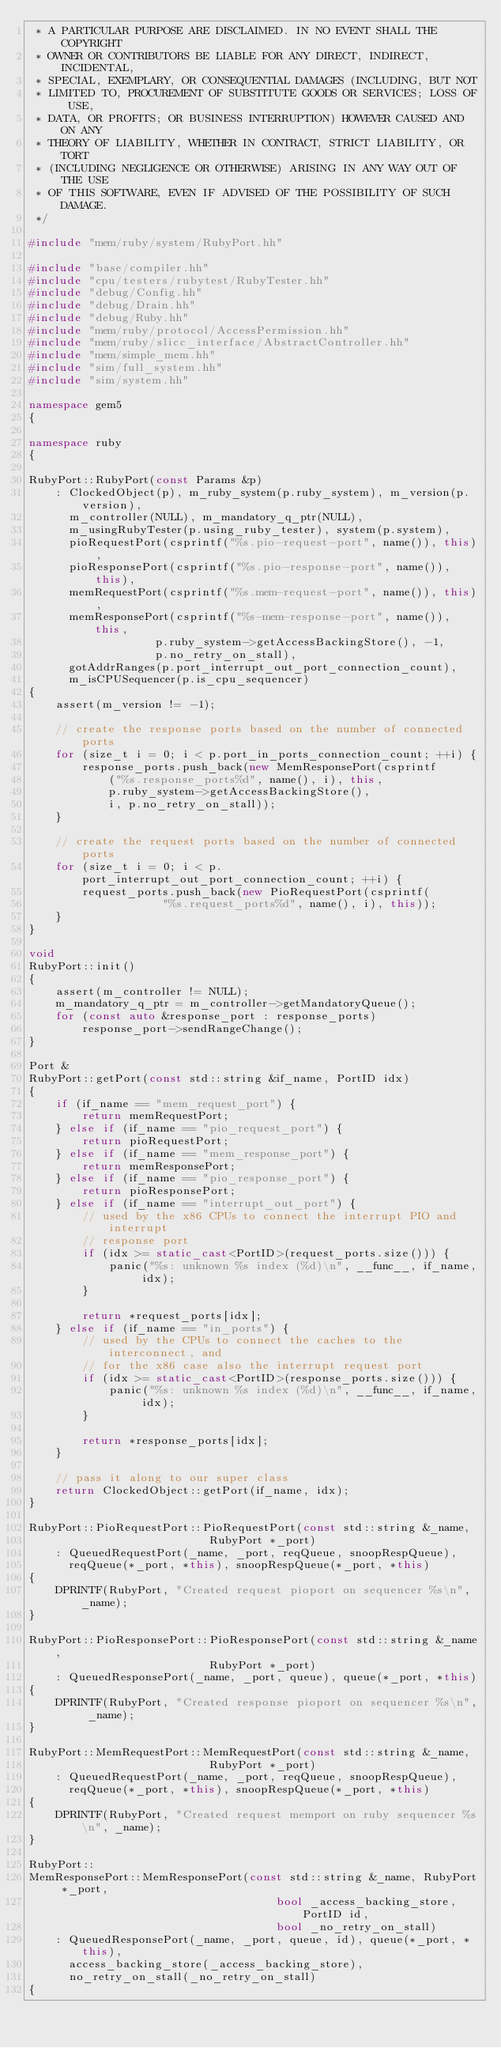<code> <loc_0><loc_0><loc_500><loc_500><_C++_> * A PARTICULAR PURPOSE ARE DISCLAIMED. IN NO EVENT SHALL THE COPYRIGHT
 * OWNER OR CONTRIBUTORS BE LIABLE FOR ANY DIRECT, INDIRECT, INCIDENTAL,
 * SPECIAL, EXEMPLARY, OR CONSEQUENTIAL DAMAGES (INCLUDING, BUT NOT
 * LIMITED TO, PROCUREMENT OF SUBSTITUTE GOODS OR SERVICES; LOSS OF USE,
 * DATA, OR PROFITS; OR BUSINESS INTERRUPTION) HOWEVER CAUSED AND ON ANY
 * THEORY OF LIABILITY, WHETHER IN CONTRACT, STRICT LIABILITY, OR TORT
 * (INCLUDING NEGLIGENCE OR OTHERWISE) ARISING IN ANY WAY OUT OF THE USE
 * OF THIS SOFTWARE, EVEN IF ADVISED OF THE POSSIBILITY OF SUCH DAMAGE.
 */

#include "mem/ruby/system/RubyPort.hh"

#include "base/compiler.hh"
#include "cpu/testers/rubytest/RubyTester.hh"
#include "debug/Config.hh"
#include "debug/Drain.hh"
#include "debug/Ruby.hh"
#include "mem/ruby/protocol/AccessPermission.hh"
#include "mem/ruby/slicc_interface/AbstractController.hh"
#include "mem/simple_mem.hh"
#include "sim/full_system.hh"
#include "sim/system.hh"

namespace gem5
{

namespace ruby
{

RubyPort::RubyPort(const Params &p)
    : ClockedObject(p), m_ruby_system(p.ruby_system), m_version(p.version),
      m_controller(NULL), m_mandatory_q_ptr(NULL),
      m_usingRubyTester(p.using_ruby_tester), system(p.system),
      pioRequestPort(csprintf("%s.pio-request-port", name()), this),
      pioResponsePort(csprintf("%s.pio-response-port", name()), this),
      memRequestPort(csprintf("%s.mem-request-port", name()), this),
      memResponsePort(csprintf("%s-mem-response-port", name()), this,
                   p.ruby_system->getAccessBackingStore(), -1,
                   p.no_retry_on_stall),
      gotAddrRanges(p.port_interrupt_out_port_connection_count),
      m_isCPUSequencer(p.is_cpu_sequencer)
{
    assert(m_version != -1);

    // create the response ports based on the number of connected ports
    for (size_t i = 0; i < p.port_in_ports_connection_count; ++i) {
        response_ports.push_back(new MemResponsePort(csprintf
            ("%s.response_ports%d", name(), i), this,
            p.ruby_system->getAccessBackingStore(),
            i, p.no_retry_on_stall));
    }

    // create the request ports based on the number of connected ports
    for (size_t i = 0; i < p.port_interrupt_out_port_connection_count; ++i) {
        request_ports.push_back(new PioRequestPort(csprintf(
                    "%s.request_ports%d", name(), i), this));
    }
}

void
RubyPort::init()
{
    assert(m_controller != NULL);
    m_mandatory_q_ptr = m_controller->getMandatoryQueue();
    for (const auto &response_port : response_ports)
        response_port->sendRangeChange();
}

Port &
RubyPort::getPort(const std::string &if_name, PortID idx)
{
    if (if_name == "mem_request_port") {
        return memRequestPort;
    } else if (if_name == "pio_request_port") {
        return pioRequestPort;
    } else if (if_name == "mem_response_port") {
        return memResponsePort;
    } else if (if_name == "pio_response_port") {
        return pioResponsePort;
    } else if (if_name == "interrupt_out_port") {
        // used by the x86 CPUs to connect the interrupt PIO and interrupt
        // response port
        if (idx >= static_cast<PortID>(request_ports.size())) {
            panic("%s: unknown %s index (%d)\n", __func__, if_name, idx);
        }

        return *request_ports[idx];
    } else if (if_name == "in_ports") {
        // used by the CPUs to connect the caches to the interconnect, and
        // for the x86 case also the interrupt request port
        if (idx >= static_cast<PortID>(response_ports.size())) {
            panic("%s: unknown %s index (%d)\n", __func__, if_name, idx);
        }

        return *response_ports[idx];
    }

    // pass it along to our super class
    return ClockedObject::getPort(if_name, idx);
}

RubyPort::PioRequestPort::PioRequestPort(const std::string &_name,
                           RubyPort *_port)
    : QueuedRequestPort(_name, _port, reqQueue, snoopRespQueue),
      reqQueue(*_port, *this), snoopRespQueue(*_port, *this)
{
    DPRINTF(RubyPort, "Created request pioport on sequencer %s\n", _name);
}

RubyPort::PioResponsePort::PioResponsePort(const std::string &_name,
                           RubyPort *_port)
    : QueuedResponsePort(_name, _port, queue), queue(*_port, *this)
{
    DPRINTF(RubyPort, "Created response pioport on sequencer %s\n", _name);
}

RubyPort::MemRequestPort::MemRequestPort(const std::string &_name,
                           RubyPort *_port)
    : QueuedRequestPort(_name, _port, reqQueue, snoopRespQueue),
      reqQueue(*_port, *this), snoopRespQueue(*_port, *this)
{
    DPRINTF(RubyPort, "Created request memport on ruby sequencer %s\n", _name);
}

RubyPort::
MemResponsePort::MemResponsePort(const std::string &_name, RubyPort *_port,
                                     bool _access_backing_store, PortID id,
                                     bool _no_retry_on_stall)
    : QueuedResponsePort(_name, _port, queue, id), queue(*_port, *this),
      access_backing_store(_access_backing_store),
      no_retry_on_stall(_no_retry_on_stall)
{</code> 